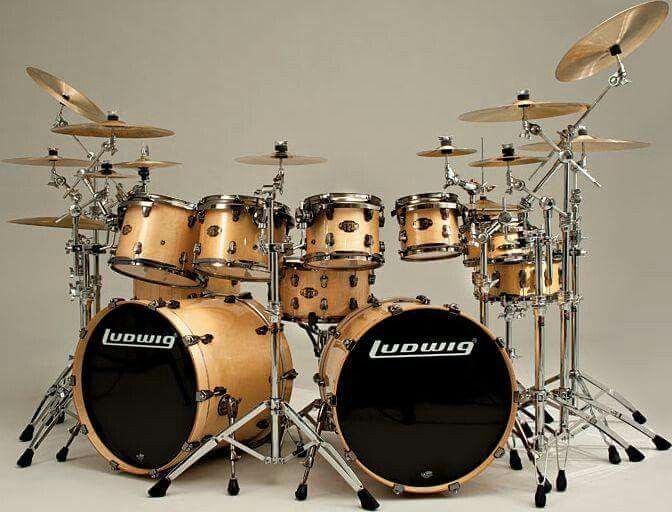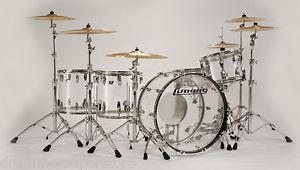The first image is the image on the left, the second image is the image on the right. Evaluate the accuracy of this statement regarding the images: "Each image shows a drum kit, but only one image features a drum kit with at least one black-faced drum that is turned on its side.". Is it true? Answer yes or no. Yes. 